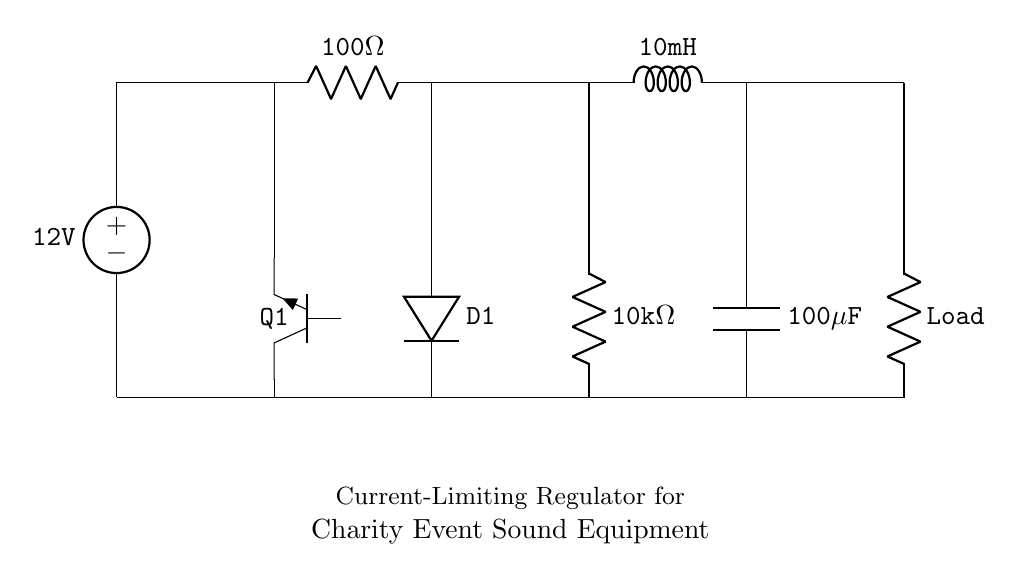What is the input voltage of the regulator? The input voltage is specified as 12V, which is indicated by the voltage source symbol at the top of the circuit diagram.
Answer: 12V What type of transistor is used in the circuit? The circuit uses an NPN transistor, as indicated by the label 'Tnpn' for the component, which denotes it is a type of NPN transistor (Q1).
Answer: NPN What is the resistance value of R1? The resistor labeled R1 has a value of 100 ohms, as shown directly in the circuit diagram next to the component symbol.
Answer: 100 ohms What is the capacitance of C1? The capacitor labeled C1 has a capacitance of 100 microfarads, as it is clearly marked in the circuit with the symbol for a capacitor and the corresponding value.
Answer: 100 microfarads How many components are connected in the output path? There are three components in the output path, which are the resistor (labeled as Load), the capacitor (C1), and the 10k ohm resistor (R2), calculating the visible output sequence.
Answer: 3 What is the purpose of the diode in this circuit? The diode D1 is used for rectifying current, ensuring that current flows in the correct direction only, as evidenced by its position in the circuit after the transistor and before the load.
Answer: Rectification What would happen if the load resistance is too low? If the load resistance is too low, it may exceed the current ratings of the transistor and other components, leading to potential overload and failure; this is due to the current limiting regulated design which aims to protect against such scenarios.
Answer: Overload 